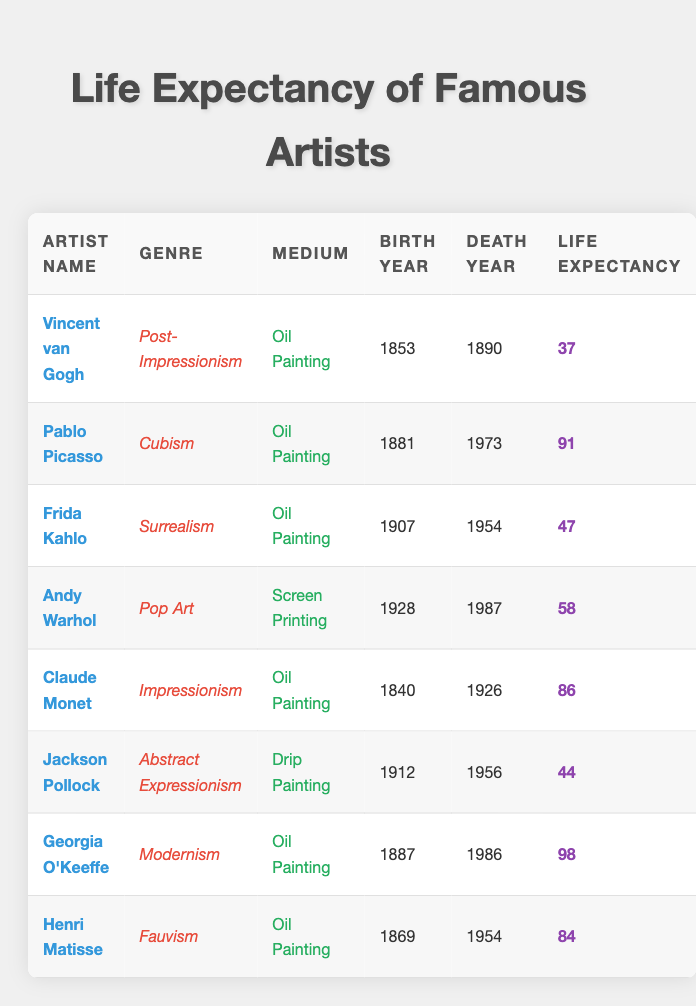What is the life expectancy of Pablo Picasso? According to the table, Pablo Picasso has a life expectancy of 91 years, as indicated in the relevant row under the "Life Expectancy" column.
Answer: 91 Which artist had the shortest life expectancy? Vincent van Gogh had the shortest life expectancy at 37 years, which is the lowest value listed in the "Life Expectancy" column.
Answer: 37 How many artists in the table lived beyond 80 years? The artists who lived beyond 80 years are Pablo Picasso (91), Claude Monet (86), Georgia O'Keeffe (98), and Henri Matisse (84). This totals to four artists, as each of their life expectancies is greater than 80.
Answer: 4 What is the average life expectancy of the artists listed in the table? To calculate the average life expectancy, we sum the life expectancies: (37 + 91 + 47 + 58 + 86 + 44 + 98 + 84) = 445. There are 8 artists, so the average is 445/8 = 55.625, which rounds to approximately 56.
Answer: 56 Did any artist in the table create artworks using screen printing as their medium? Yes, Andy Warhol is the only artist listed who used screen printing as his medium, as shown in the "Medium" column.
Answer: Yes Which genre had the highest life expectancy among the listed artists? By examining the life expectancies of artists within their genres, we find that Georgia O'Keeffe in Modernism had the highest life expectancy at 98 years, which is greater than all other genres listed.
Answer: Modernism How many artists grouped by the medium "Oil Painting" lived to be 80 years or older? Among the artists who used "Oil Painting" as their medium, we have Claude Monet (86), Georgia O'Keeffe (98), and Henri Matisse (84). Therefore, there are three artists in this medium who lived to be 80 or older.
Answer: 3 Is it true that all artists in the table are oil painters? No, this statement is false since there are two artists, Andy Warhol (Screen Printing) and Jackson Pollock (Drip Painting), who do not use oil painting as their medium.
Answer: No 